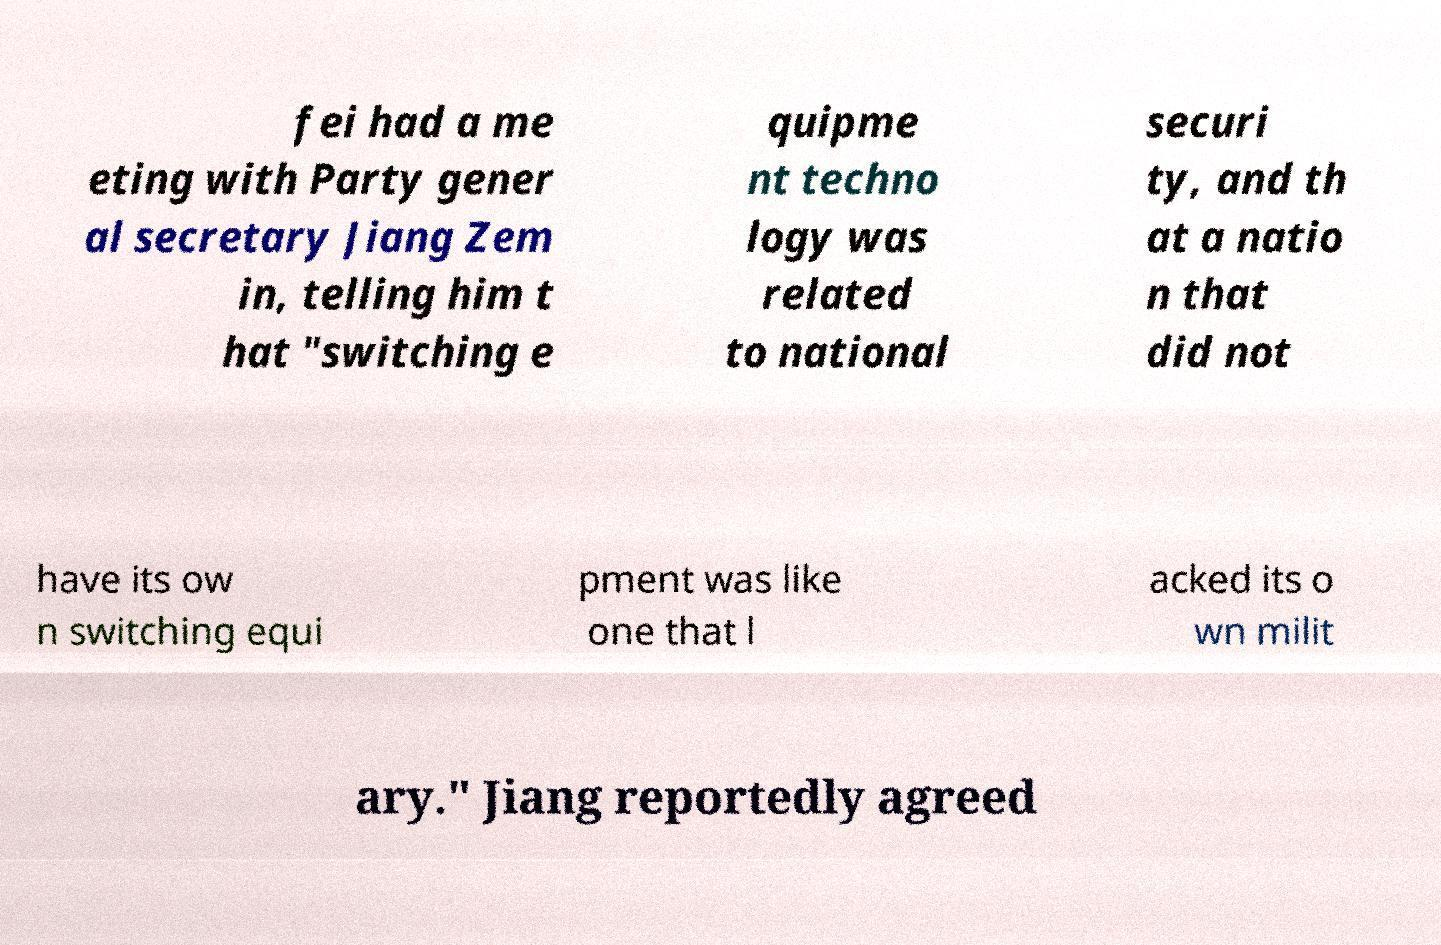There's text embedded in this image that I need extracted. Can you transcribe it verbatim? fei had a me eting with Party gener al secretary Jiang Zem in, telling him t hat "switching e quipme nt techno logy was related to national securi ty, and th at a natio n that did not have its ow n switching equi pment was like one that l acked its o wn milit ary." Jiang reportedly agreed 